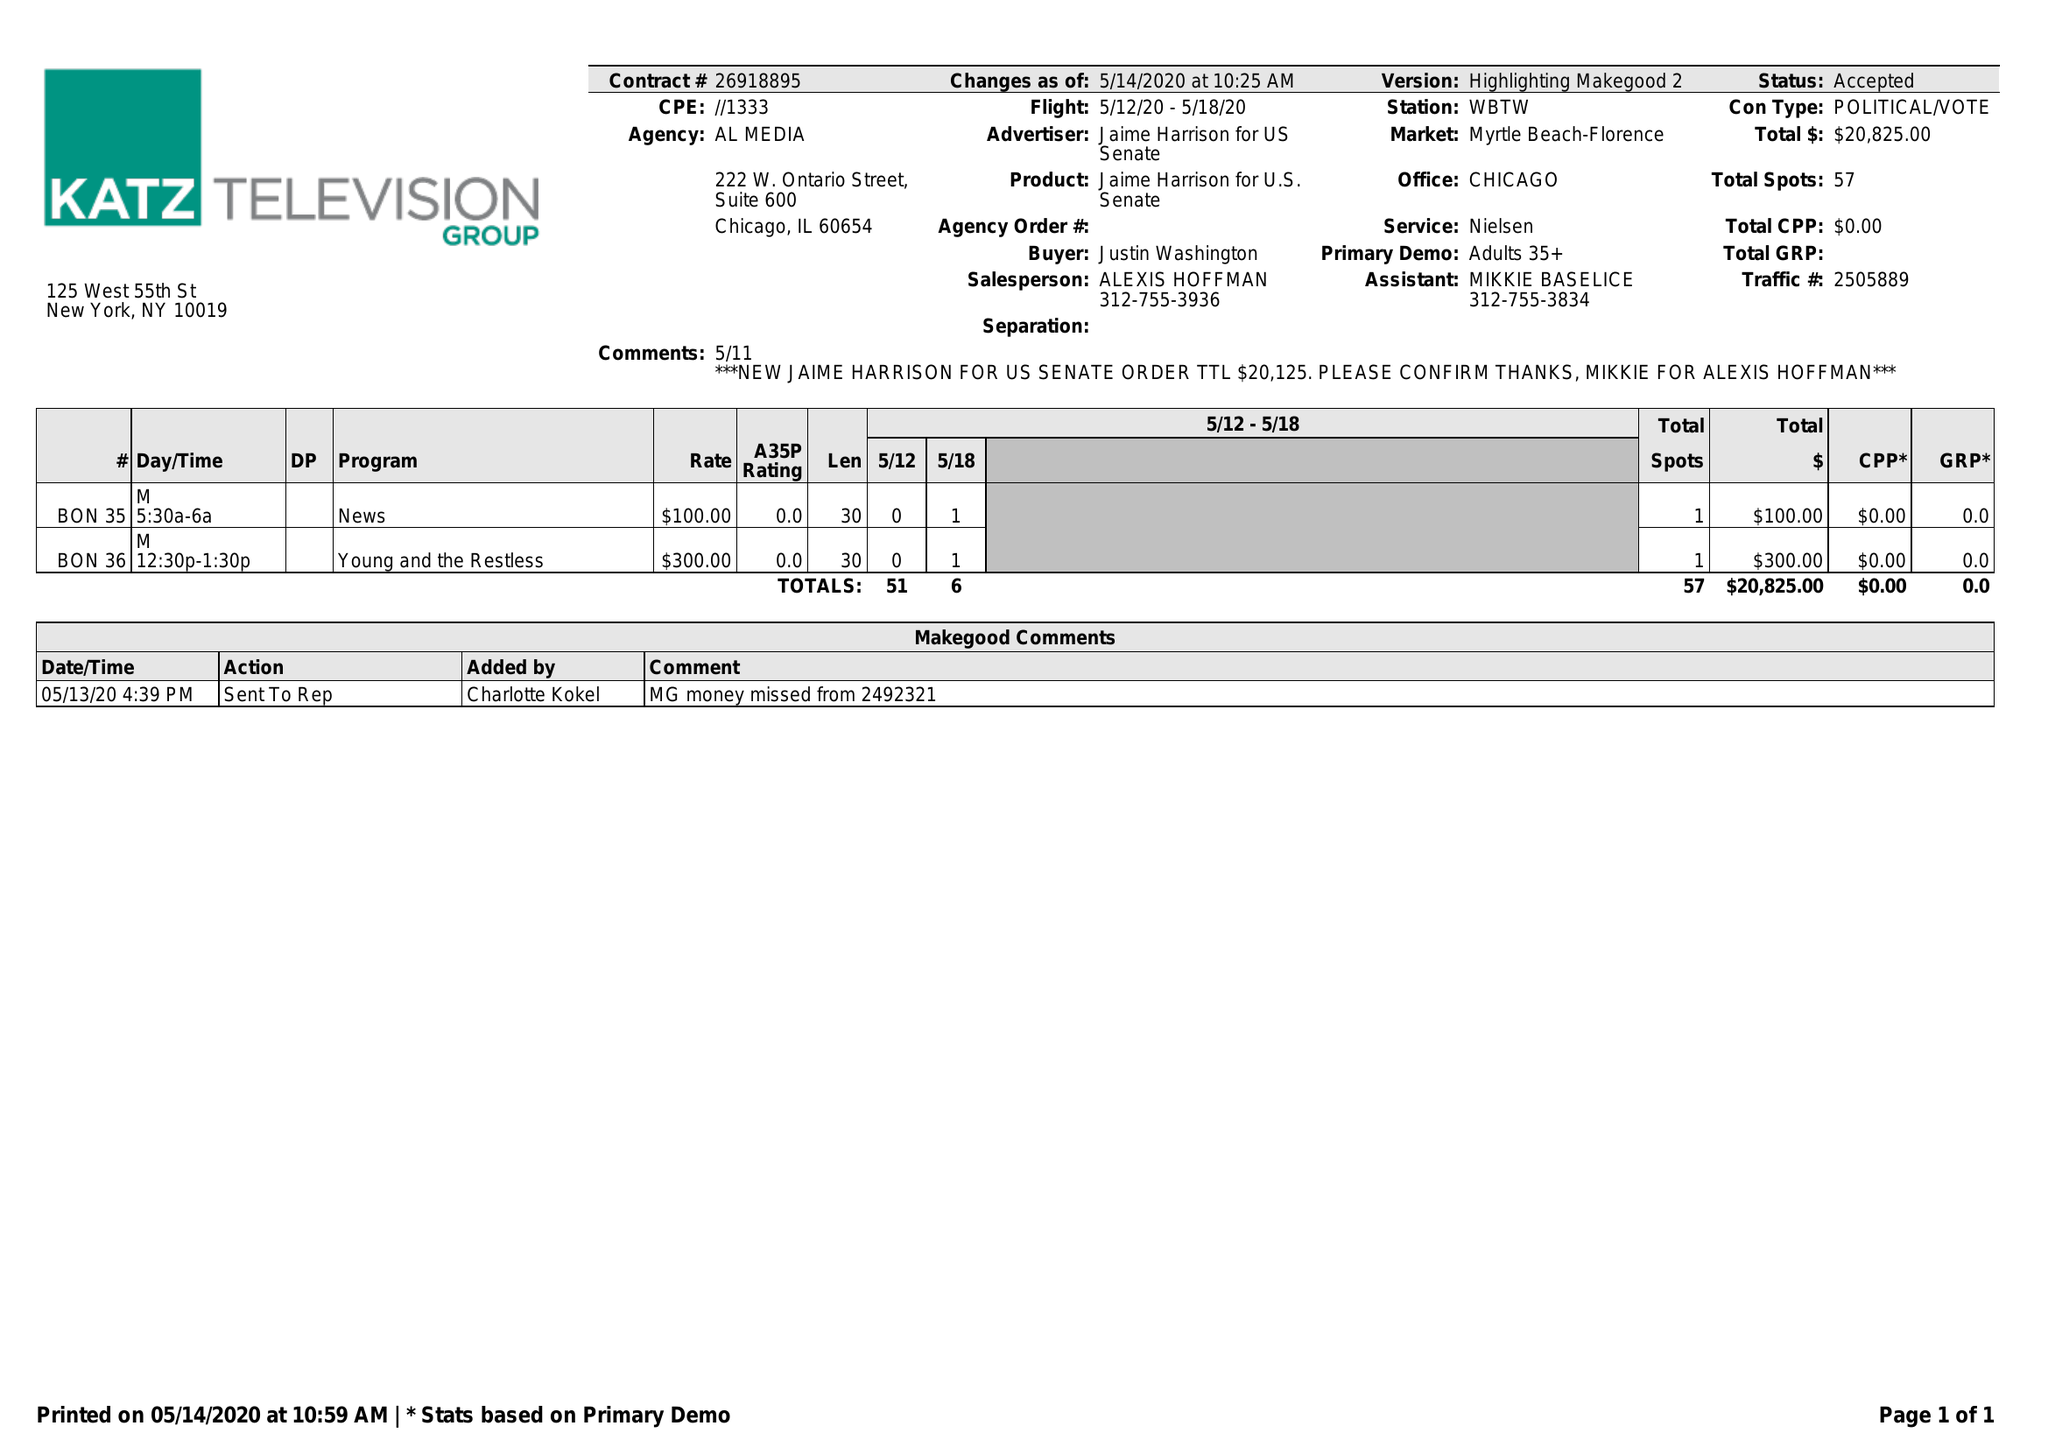What is the value for the contract_num?
Answer the question using a single word or phrase. 26918895 